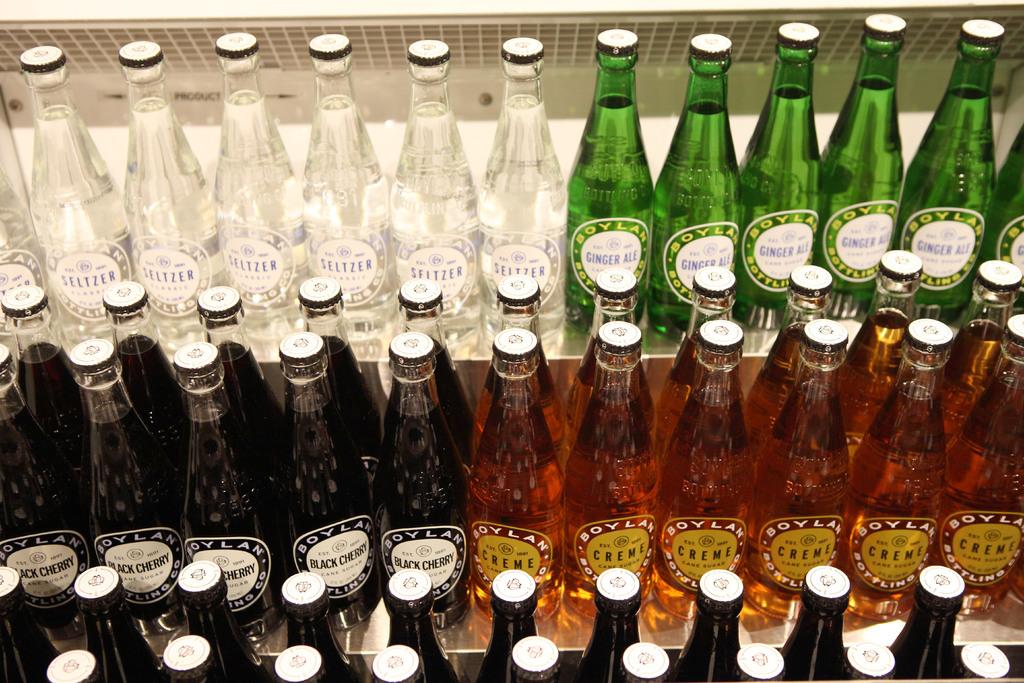What is the name of the company who makes these drinks?
Your answer should be compact. Boylan. What flavor is the black drink?
Offer a very short reply. Black cherry. 